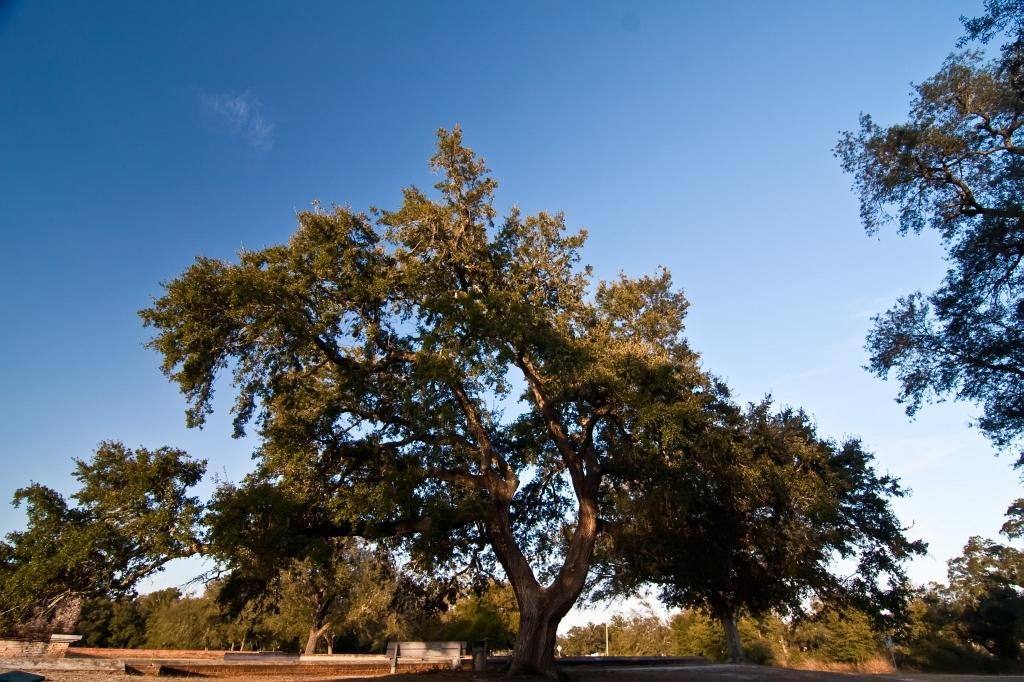What type of vegetation can be seen in the image? There are trees in the image. What type of seating is present in the image? There is a bench in the image. What other object can be seen in the image? There is a pole in the image. What is visible in the background of the image? The sky is visible in the background of the image. What type of vegetable is growing on the pole in the image? There is no vegetable growing on the pole in the image; it is a pole without any vegetation. Can you describe the act being performed by the trees in the image? Trees are stationary objects and do not perform acts; they are simply part of the natural environment in the image. 